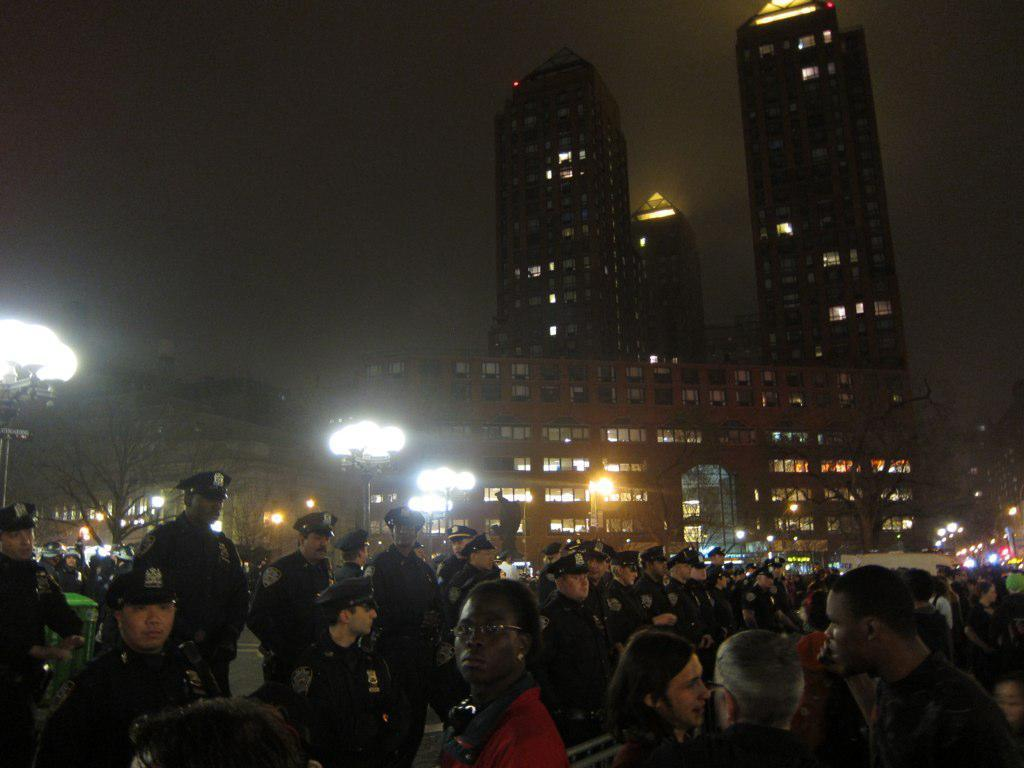What is the main setting of the image? The image depicts a busy street. Can you describe the activity on the street? There are many people on the road. What can be seen in the background of the image? There is a building visible in the background. What type of lighting is present in the image? There are lights on a pole in the image. Can you see a collar on any of the people in the image? There is no collar visible on any of the people in the image. Is there a lake present in the image? There is no lake present in the image; it depicts a busy street with a building in the background. 